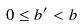<formula> <loc_0><loc_0><loc_500><loc_500>0 \leq b ^ { \prime } < b</formula> 